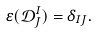Convert formula to latex. <formula><loc_0><loc_0><loc_500><loc_500>\varepsilon ( \mathcal { D } _ { J } ^ { I } ) = \delta _ { I J } .</formula> 